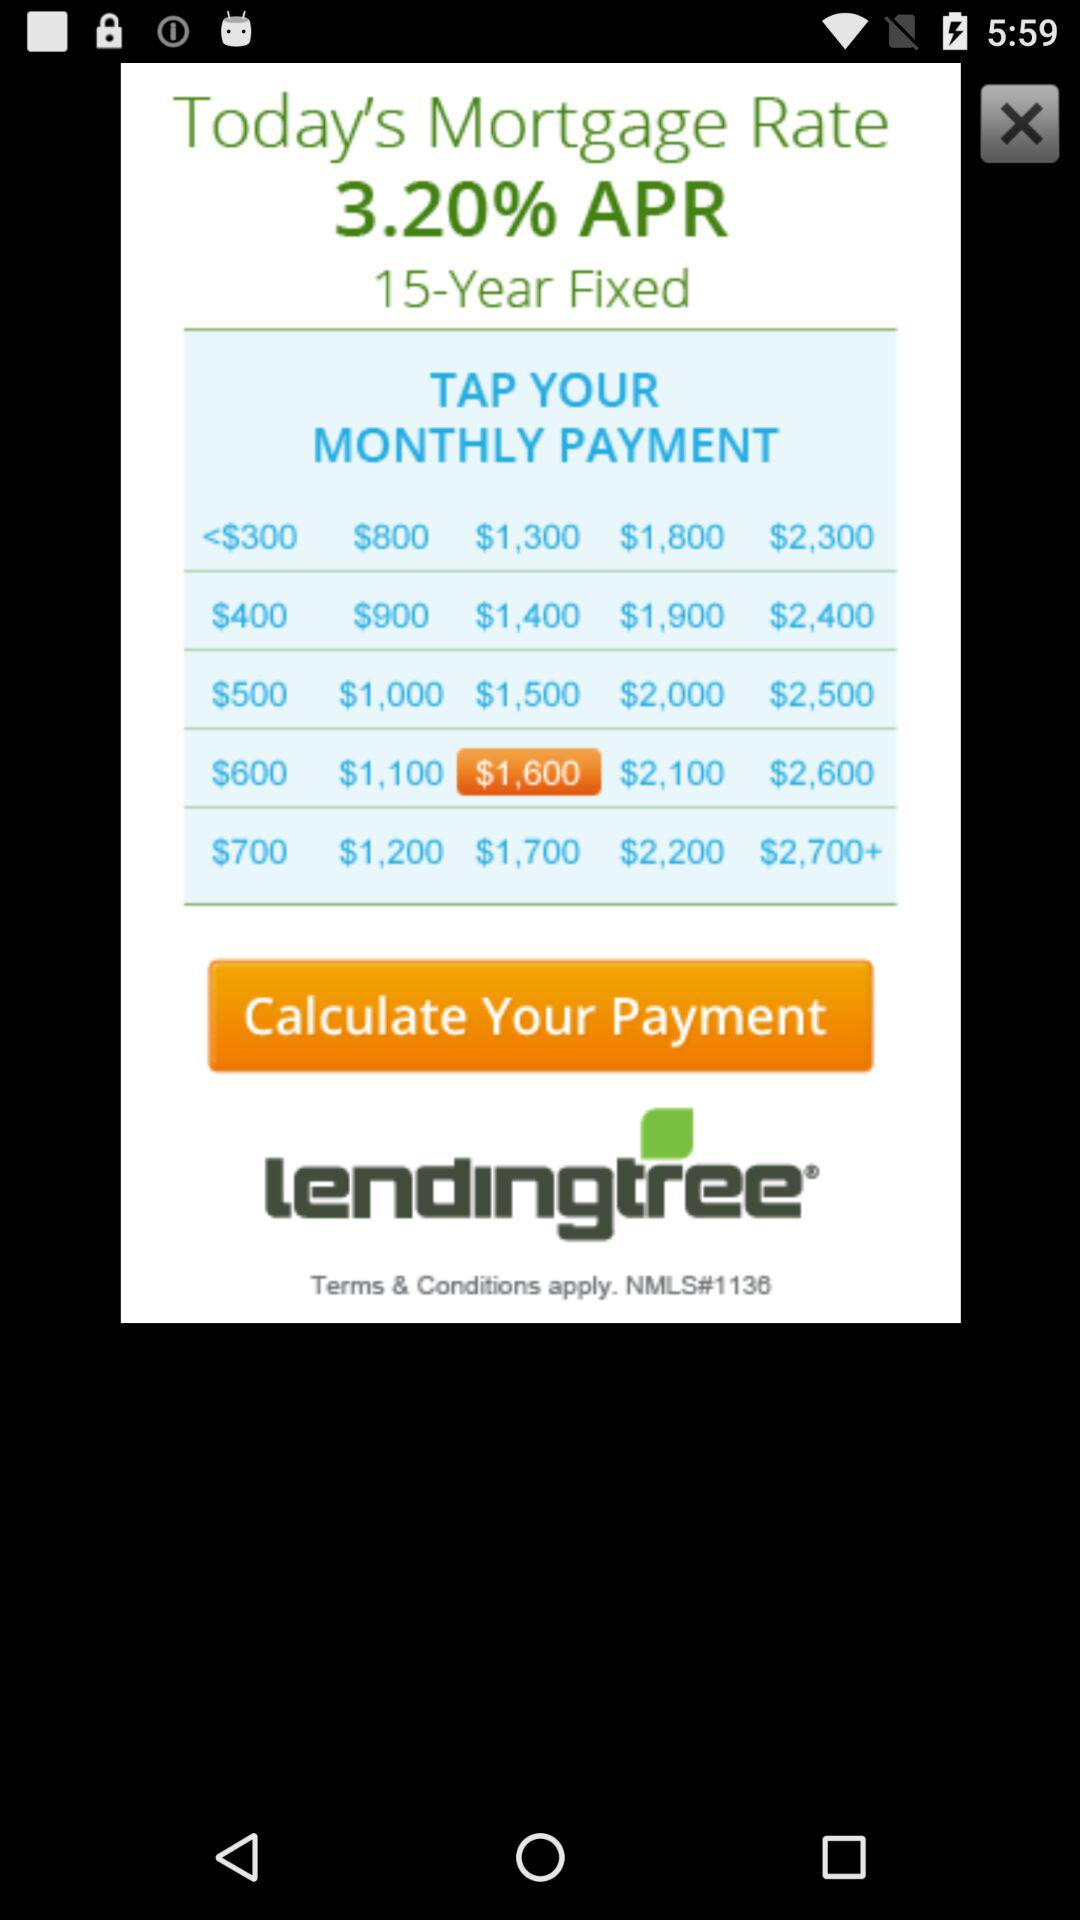What's the mortgage rate? The mortgage rate is 3.20%. 